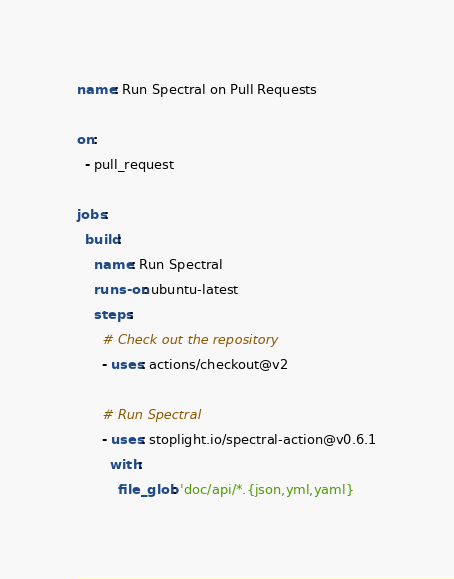<code> <loc_0><loc_0><loc_500><loc_500><_YAML_>name: Run Spectral on Pull Requests

on:
  - pull_request
    
jobs:
  build:
    name: Run Spectral
    runs-on: ubuntu-latest
    steps:
      # Check out the repository
      - uses: actions/checkout@v2
        
      # Run Spectral
      - uses: stoplight.io/spectral-action@v0.6.1
        with:
          file_glob: 'doc/api/*.{json,yml,yaml}
</code> 